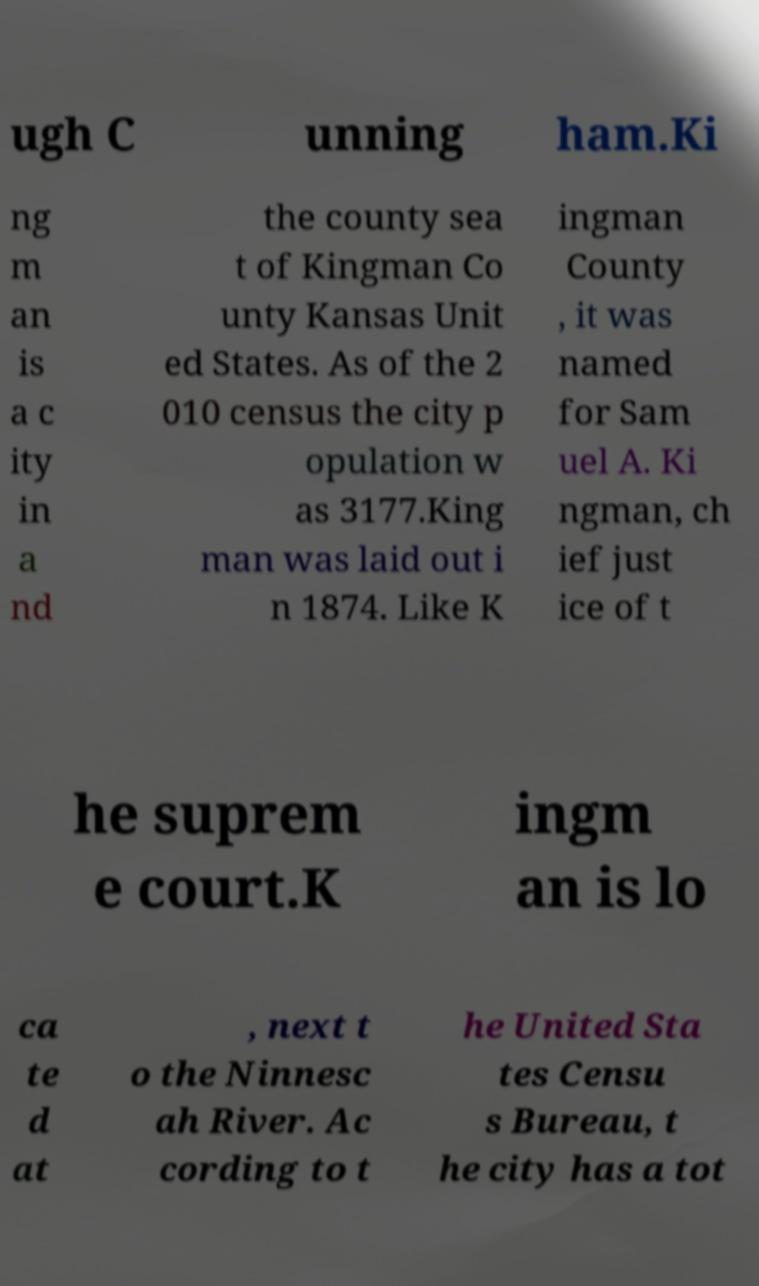For documentation purposes, I need the text within this image transcribed. Could you provide that? ugh C unning ham.Ki ng m an is a c ity in a nd the county sea t of Kingman Co unty Kansas Unit ed States. As of the 2 010 census the city p opulation w as 3177.King man was laid out i n 1874. Like K ingman County , it was named for Sam uel A. Ki ngman, ch ief just ice of t he suprem e court.K ingm an is lo ca te d at , next t o the Ninnesc ah River. Ac cording to t he United Sta tes Censu s Bureau, t he city has a tot 